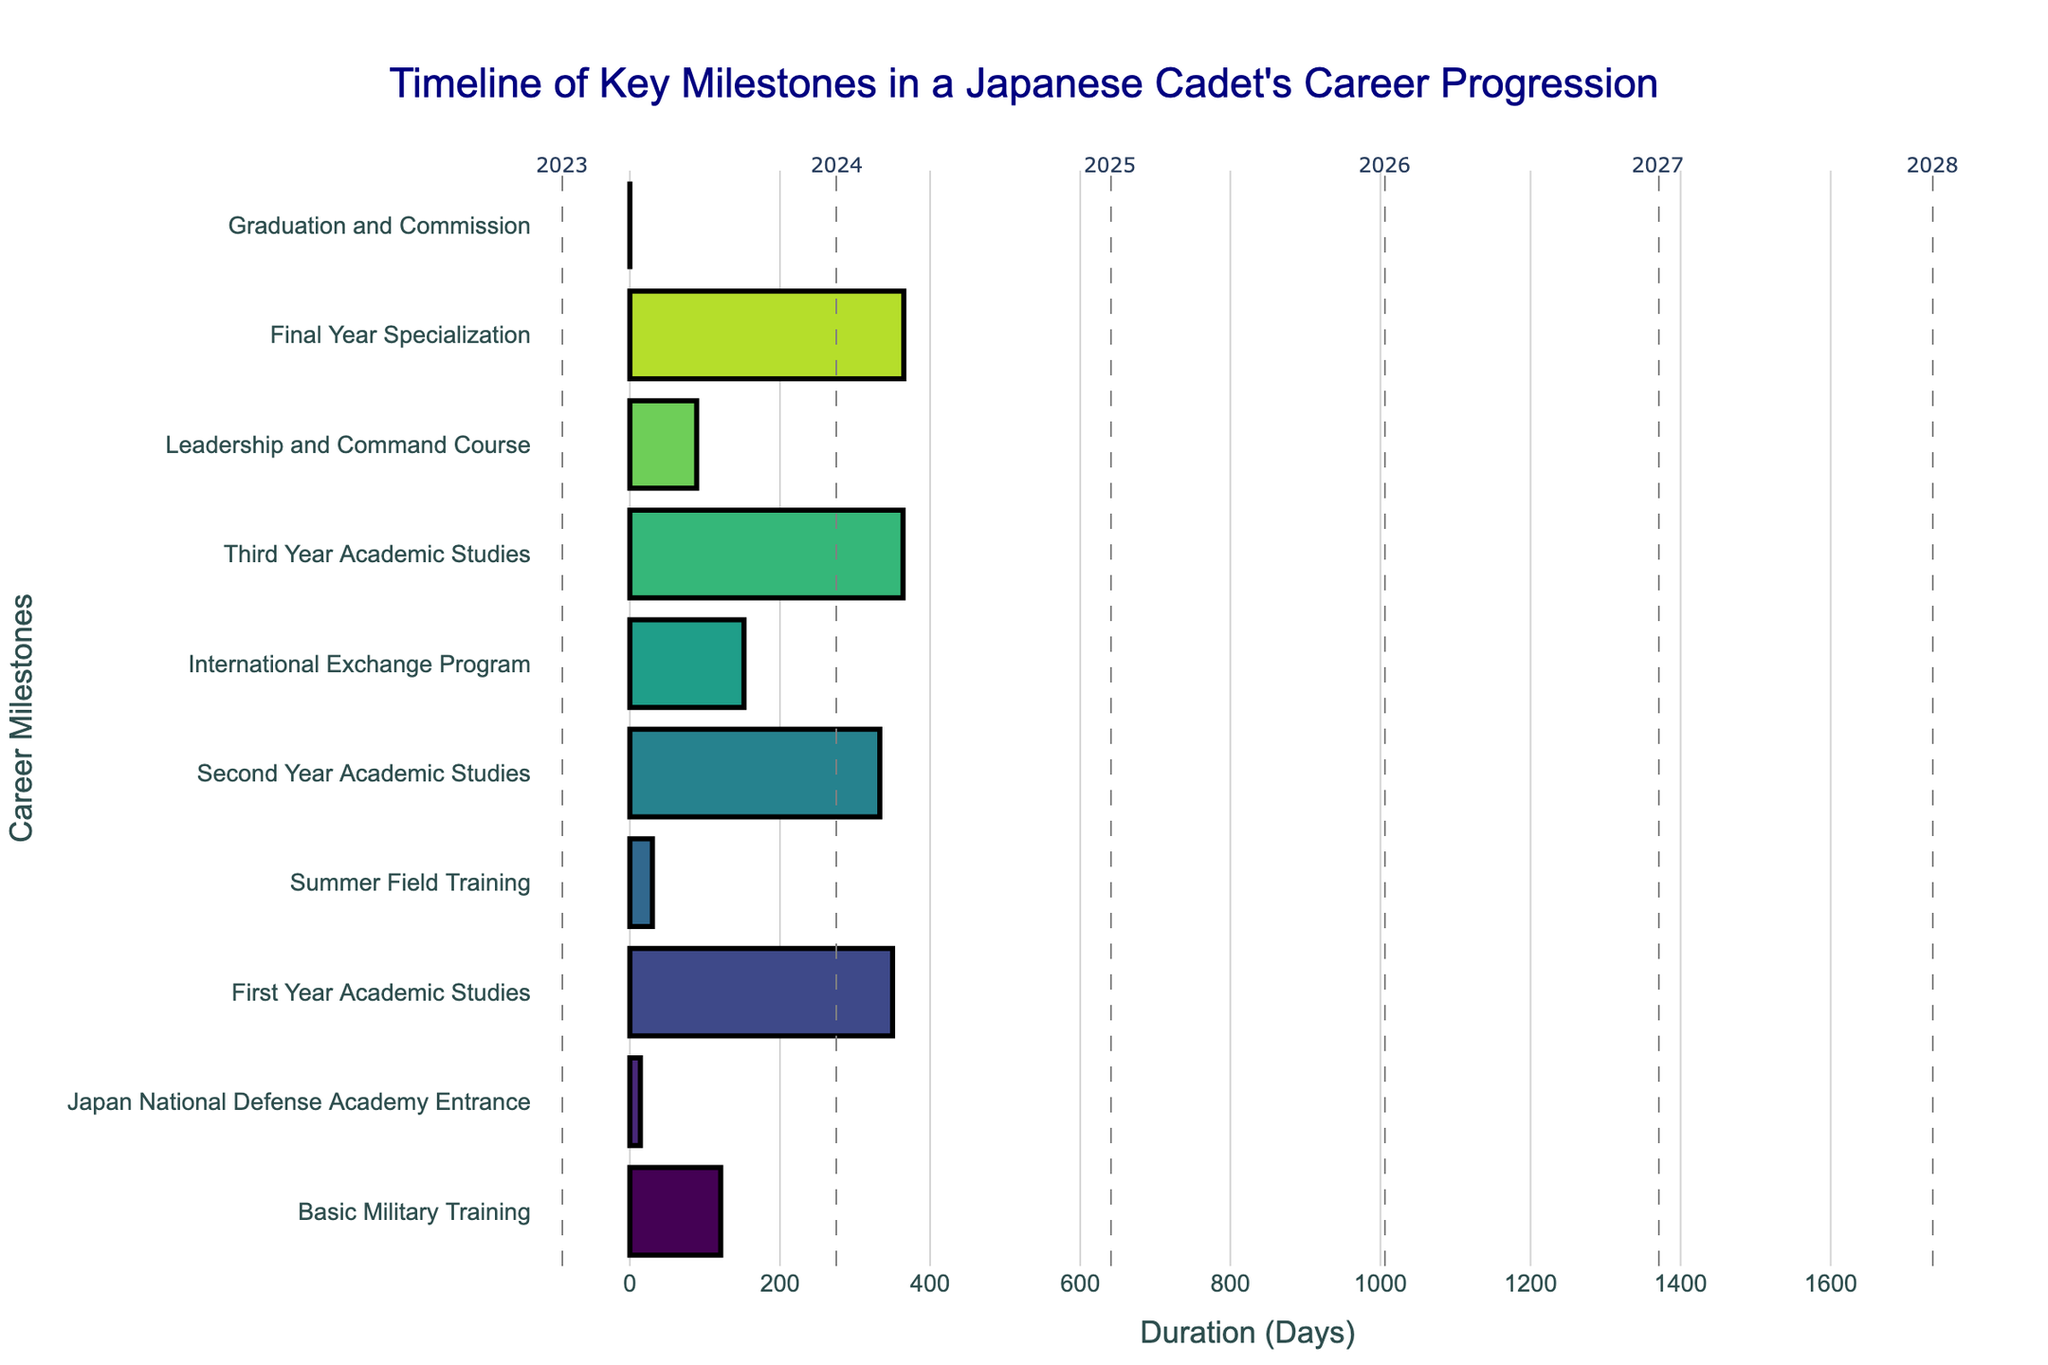What's the title of the Gantt chart? The title is usually located at the top of the chart. In this case, it reads "Timeline of Key Milestones in a Japanese Cadet's Career Progression."
Answer: Timeline of Key Milestones in a Japanese Cadet's Career Progression How many tasks are represented in the cadet's career progression? By counting the number of distinct tasks listed along the y-axis, we can see that there are 10 tasks in total.
Answer: 10 Which task has the longest duration? To find the task with the longest duration, we compare all the horizontal bars. The "Final Year Specialization" bar spans the most considerable duration from April 1, 2027, to March 31, 2028.
Answer: Final Year Specialization When does the "International Exchange Program" start and end? According to the hover text for the "International Exchange Program" bar: it starts on August 1, 2025, and ends on December 31, 2025.
Answer: August 1, 2025 to December 31, 2025 Which tasks occur entirely within the year 2024? Comparing the start and end dates of each task with the calendar year 2024 reveals that "First Year Academic Studies" ends in July 2024 and "Summer Field Training" takes place in August 2024. Only "Summer Field Training" falls entirely within 2024.
Answer: Summer Field Training How many months does the "Leadership and Command Course" last? The course starts on January 1, 2027, and ends on March 31, 2027. Counting the months between these dates, we have January, February, and March, making it a 3-month duration.
Answer: 3 months What is the average duration of all tasks in days? First, calculate the duration of each task in days, sum them up, and then divide by the number of tasks. Steps: Basic Military Training (122 days), Japan National Defense Academy Entrance (15 days), First Year Academic Studies (350 days), Summer Field Training (31 days), Second Year Academic Studies (334 days), International Exchange Program (153 days), Third Year Academic Studies (365 days), Leadership and Command Course (90 days), Final Year Specialization (365 days), Graduation and Commission (1 day). Sum is 1826 days. Average is 1826 / 10 = 182.6 days.
Answer: 182.6 days Which task immediately follows the "Second Year Academic Studies"? By looking at the Gantt chart's sequence, immediately after the "Second Year Academic Studies" is the "International Exchange Program," starting on August 1, 2025.
Answer: International Exchange Program Which task has the shortest duration and what is it? Observing the lengths of all horizontal bars, the shortest duration is for the "Graduation and Commission" task, which spans only 1 day on March 31, 2028.
Answer: Graduation and Commission How do the durations of "Third Year Academic Studies" and "Final Year Specialization" compare? Compare the lengths of both bars. "Third Year Academic Studies" lasts from January 1, 2026, to December 31, 2026 (365 days), while "Final Year Specialization" lasts from April 1, 2027, to March 31, 2028 (365 days). Both have the same duration.
Answer: Same duration 